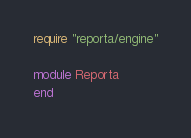<code> <loc_0><loc_0><loc_500><loc_500><_Ruby_>require "reporta/engine"

module Reporta
end
</code> 